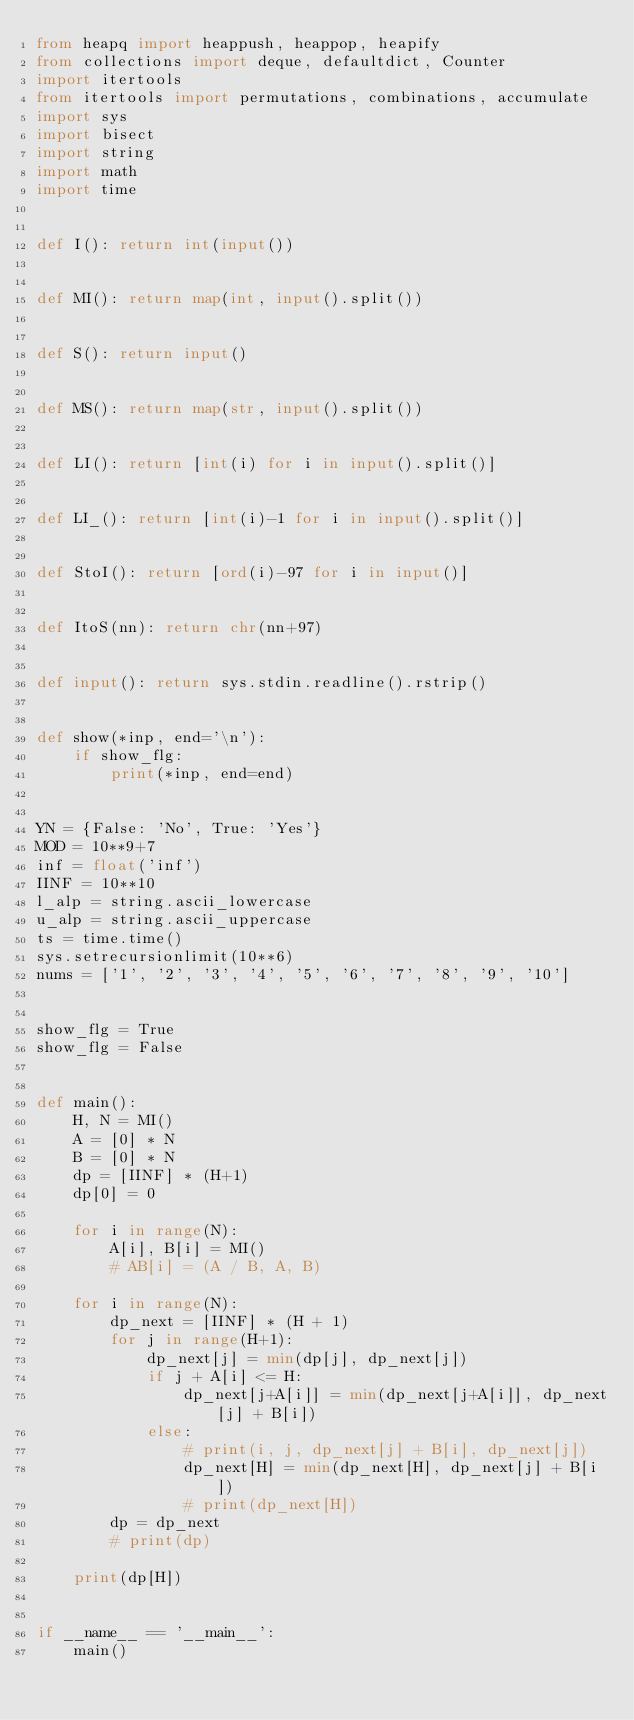<code> <loc_0><loc_0><loc_500><loc_500><_Python_>from heapq import heappush, heappop, heapify
from collections import deque, defaultdict, Counter
import itertools
from itertools import permutations, combinations, accumulate
import sys
import bisect
import string
import math
import time


def I(): return int(input())


def MI(): return map(int, input().split())


def S(): return input()


def MS(): return map(str, input().split())


def LI(): return [int(i) for i in input().split()]


def LI_(): return [int(i)-1 for i in input().split()]


def StoI(): return [ord(i)-97 for i in input()]


def ItoS(nn): return chr(nn+97)


def input(): return sys.stdin.readline().rstrip()


def show(*inp, end='\n'):
    if show_flg:
        print(*inp, end=end)


YN = {False: 'No', True: 'Yes'}
MOD = 10**9+7
inf = float('inf')
IINF = 10**10
l_alp = string.ascii_lowercase
u_alp = string.ascii_uppercase
ts = time.time()
sys.setrecursionlimit(10**6)
nums = ['1', '2', '3', '4', '5', '6', '7', '8', '9', '10']


show_flg = True
show_flg = False


def main():
    H, N = MI()
    A = [0] * N
    B = [0] * N
    dp = [IINF] * (H+1)
    dp[0] = 0

    for i in range(N):
        A[i], B[i] = MI()
        # AB[i] = (A / B, A, B)

    for i in range(N):
        dp_next = [IINF] * (H + 1)
        for j in range(H+1):
            dp_next[j] = min(dp[j], dp_next[j])
            if j + A[i] <= H:
                dp_next[j+A[i]] = min(dp_next[j+A[i]], dp_next[j] + B[i])
            else:
                # print(i, j, dp_next[j] + B[i], dp_next[j])
                dp_next[H] = min(dp_next[H], dp_next[j] + B[i])
                # print(dp_next[H])
        dp = dp_next
        # print(dp)

    print(dp[H])


if __name__ == '__main__':
    main()
</code> 